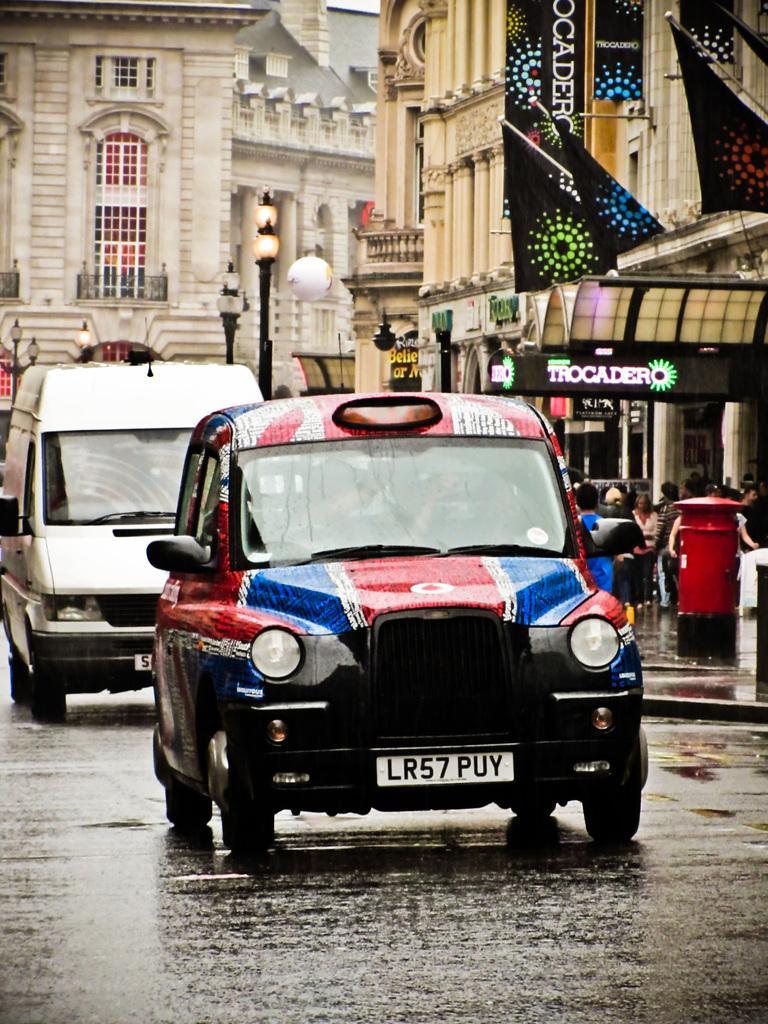Could you give a brief overview of what you see in this image? In this picture we can see vehicles on the road and in the background we can see buildings,poles,persons. 